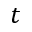<formula> <loc_0><loc_0><loc_500><loc_500>t</formula> 